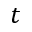<formula> <loc_0><loc_0><loc_500><loc_500>t</formula> 